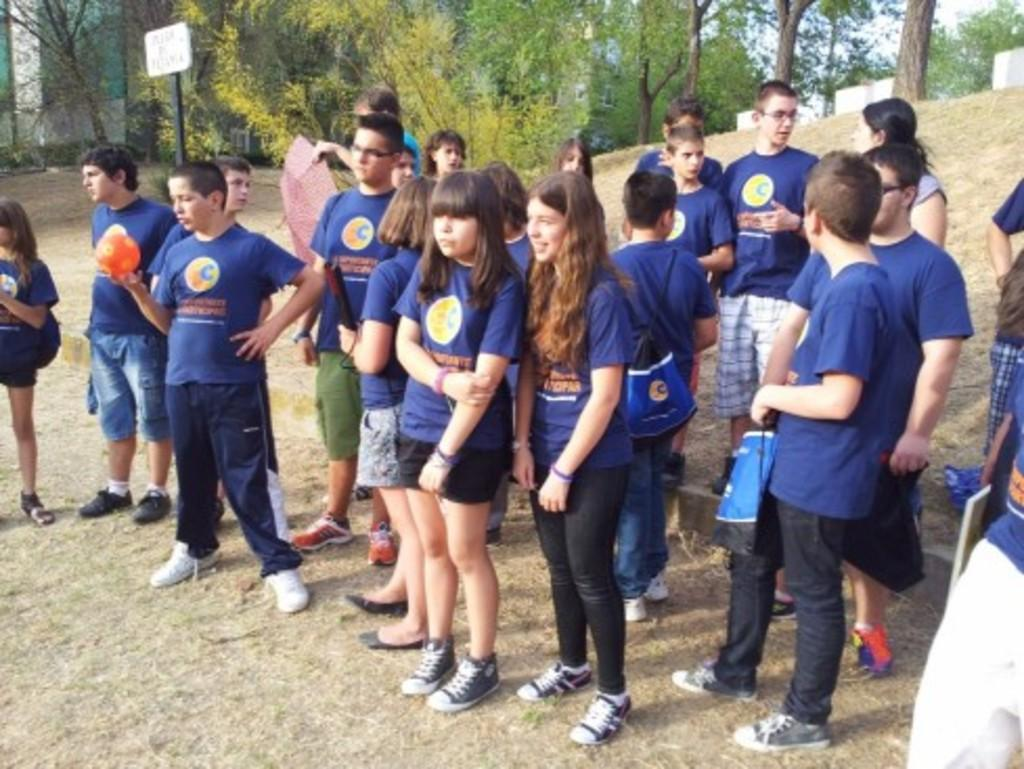What are the people in the image doing? There is a group of people standing on the ground in the image. What items can be seen in the hands of the people or on the ground? There are bags visible in the image. What object might be used for protection from the sun or rain? There is an umbrella in the image. What object might indicate the location or purpose of the area? There is a name board in the image. What other objects can be seen in the image? There are some objects in the image. What can be seen in the background of the image? There are trees in the background of the image. What type of cup can be seen in the image? There is no cup present in the image. 